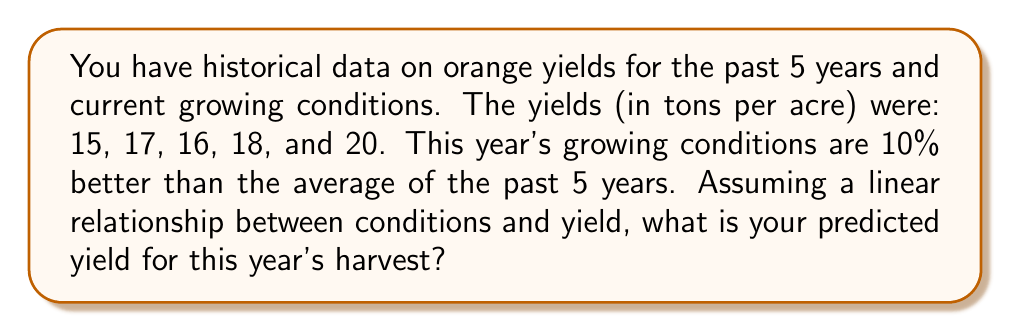Give your solution to this math problem. Let's approach this step-by-step:

1) First, calculate the average yield for the past 5 years:
   $$\text{Average} = \frac{15 + 17 + 16 + 18 + 20}{5} = \frac{86}{5} = 17.2 \text{ tons per acre}$$

2) The current growing conditions are 10% better than average. This means we need to increase our average yield by 10%.

3) To calculate a 10% increase, we multiply by 1.1:
   $$\text{Predicted Yield} = 17.2 \times 1.1$$

4) Let's perform this calculation:
   $$\text{Predicted Yield} = 17.2 \times 1.1 = 18.92 \text{ tons per acre}$$

Therefore, based on the historical data and the improved growing conditions, we predict a yield of 18.92 tons per acre for this year's harvest.
Answer: 18.92 tons per acre 